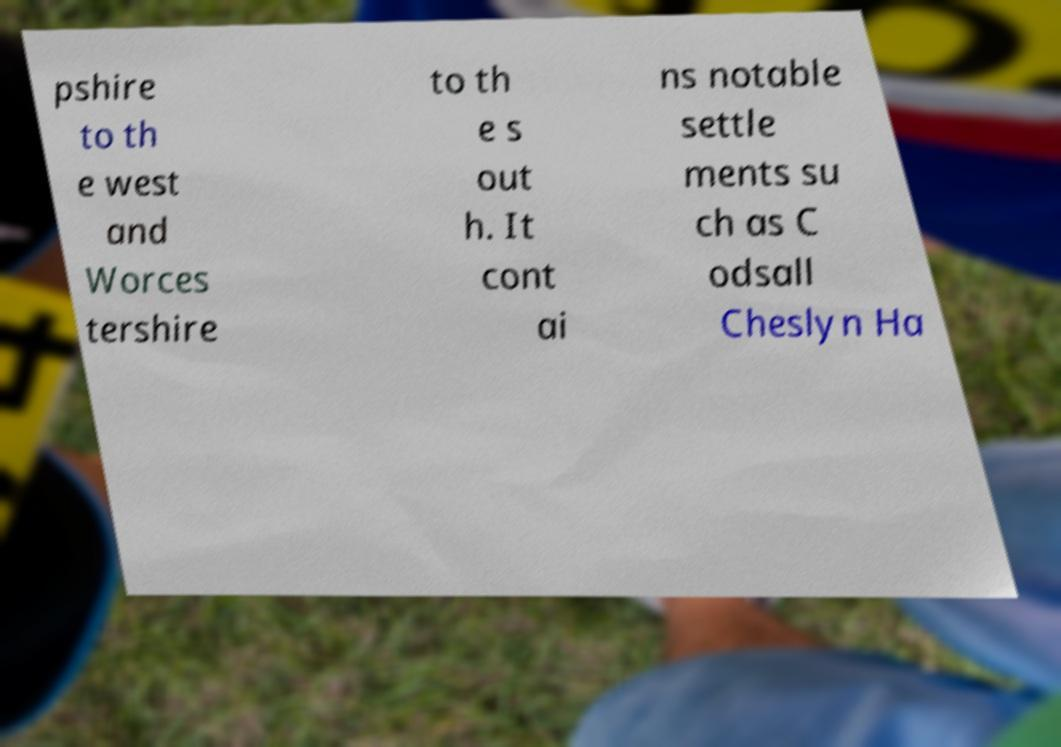Can you accurately transcribe the text from the provided image for me? pshire to th e west and Worces tershire to th e s out h. It cont ai ns notable settle ments su ch as C odsall Cheslyn Ha 